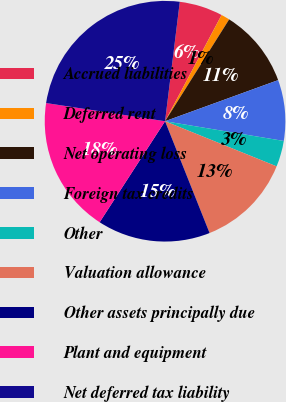<chart> <loc_0><loc_0><loc_500><loc_500><pie_chart><fcel>Accrued liabilities<fcel>Deferred rent<fcel>Net operating loss<fcel>Foreign tax credits<fcel>Other<fcel>Valuation allowance<fcel>Other assets principally due<fcel>Plant and equipment<fcel>Net deferred tax liability<nl><fcel>5.83%<fcel>1.16%<fcel>10.51%<fcel>8.17%<fcel>3.5%<fcel>12.85%<fcel>15.18%<fcel>18.27%<fcel>24.54%<nl></chart> 